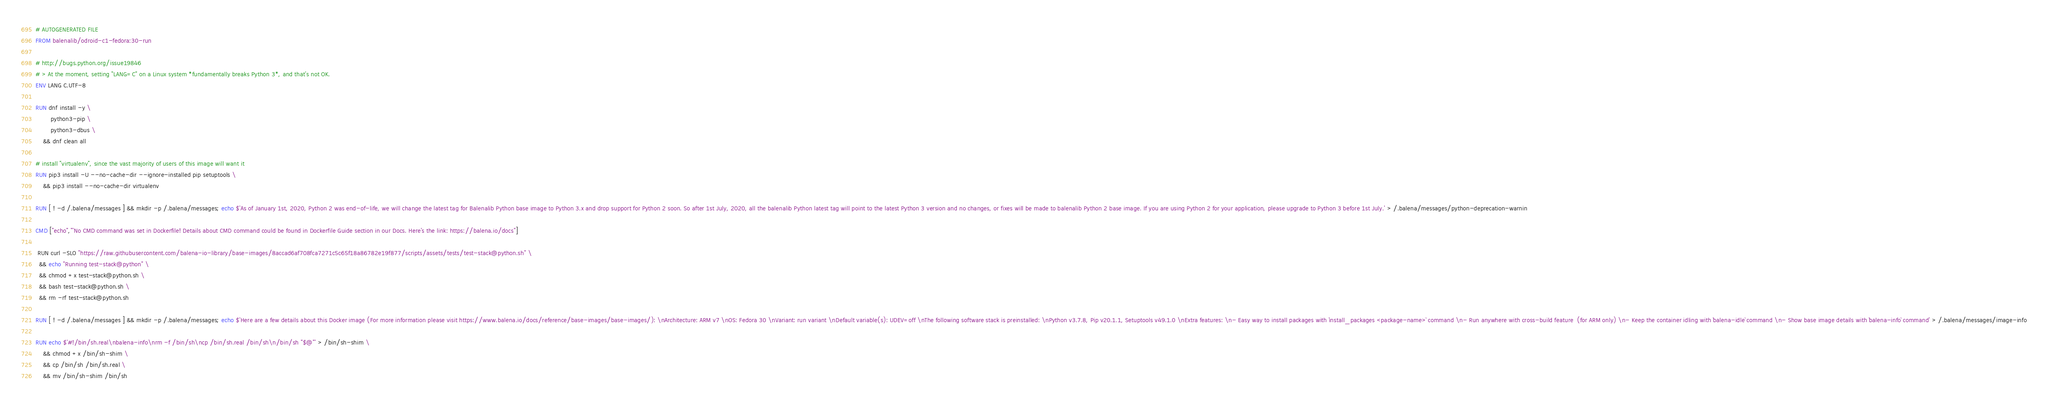<code> <loc_0><loc_0><loc_500><loc_500><_Dockerfile_># AUTOGENERATED FILE
FROM balenalib/odroid-c1-fedora:30-run

# http://bugs.python.org/issue19846
# > At the moment, setting "LANG=C" on a Linux system *fundamentally breaks Python 3*, and that's not OK.
ENV LANG C.UTF-8

RUN dnf install -y \
		python3-pip \
		python3-dbus \
	&& dnf clean all

# install "virtualenv", since the vast majority of users of this image will want it
RUN pip3 install -U --no-cache-dir --ignore-installed pip setuptools \
	&& pip3 install --no-cache-dir virtualenv

RUN [ ! -d /.balena/messages ] && mkdir -p /.balena/messages; echo $'As of January 1st, 2020, Python 2 was end-of-life, we will change the latest tag for Balenalib Python base image to Python 3.x and drop support for Python 2 soon. So after 1st July, 2020, all the balenalib Python latest tag will point to the latest Python 3 version and no changes, or fixes will be made to balenalib Python 2 base image. If you are using Python 2 for your application, please upgrade to Python 3 before 1st July.' > /.balena/messages/python-deprecation-warnin

CMD ["echo","'No CMD command was set in Dockerfile! Details about CMD command could be found in Dockerfile Guide section in our Docs. Here's the link: https://balena.io/docs"]

 RUN curl -SLO "https://raw.githubusercontent.com/balena-io-library/base-images/8accad6af708fca7271c5c65f18a86782e19f877/scripts/assets/tests/test-stack@python.sh" \
  && echo "Running test-stack@python" \
  && chmod +x test-stack@python.sh \
  && bash test-stack@python.sh \
  && rm -rf test-stack@python.sh 

RUN [ ! -d /.balena/messages ] && mkdir -p /.balena/messages; echo $'Here are a few details about this Docker image (For more information please visit https://www.balena.io/docs/reference/base-images/base-images/): \nArchitecture: ARM v7 \nOS: Fedora 30 \nVariant: run variant \nDefault variable(s): UDEV=off \nThe following software stack is preinstalled: \nPython v3.7.8, Pip v20.1.1, Setuptools v49.1.0 \nExtra features: \n- Easy way to install packages with `install_packages <package-name>` command \n- Run anywhere with cross-build feature  (for ARM only) \n- Keep the container idling with `balena-idle` command \n- Show base image details with `balena-info` command' > /.balena/messages/image-info

RUN echo $'#!/bin/sh.real\nbalena-info\nrm -f /bin/sh\ncp /bin/sh.real /bin/sh\n/bin/sh "$@"' > /bin/sh-shim \
	&& chmod +x /bin/sh-shim \
	&& cp /bin/sh /bin/sh.real \
	&& mv /bin/sh-shim /bin/sh</code> 